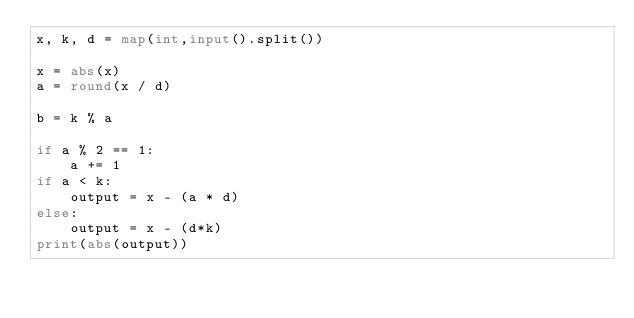Convert code to text. <code><loc_0><loc_0><loc_500><loc_500><_Python_>x, k, d = map(int,input().split())

x = abs(x)
a = round(x / d)

b = k % a

if a % 2 == 1:
    a += 1
if a < k:
    output = x - (a * d)
else:
    output = x - (d*k)
print(abs(output))

</code> 